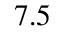Convert formula to latex. <formula><loc_0><loc_0><loc_500><loc_500>7 . 5</formula> 